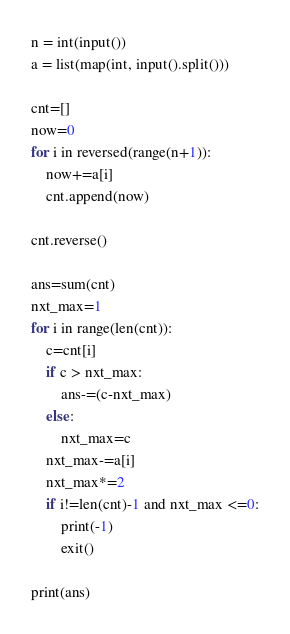<code> <loc_0><loc_0><loc_500><loc_500><_Python_>n = int(input())
a = list(map(int, input().split()))

cnt=[]
now=0
for i in reversed(range(n+1)):
    now+=a[i]
    cnt.append(now)

cnt.reverse()

ans=sum(cnt)
nxt_max=1
for i in range(len(cnt)):
    c=cnt[i]
    if c > nxt_max:
        ans-=(c-nxt_max)
    else:
        nxt_max=c
    nxt_max-=a[i]
    nxt_max*=2
    if i!=len(cnt)-1 and nxt_max <=0:
        print(-1)
        exit()

print(ans)</code> 